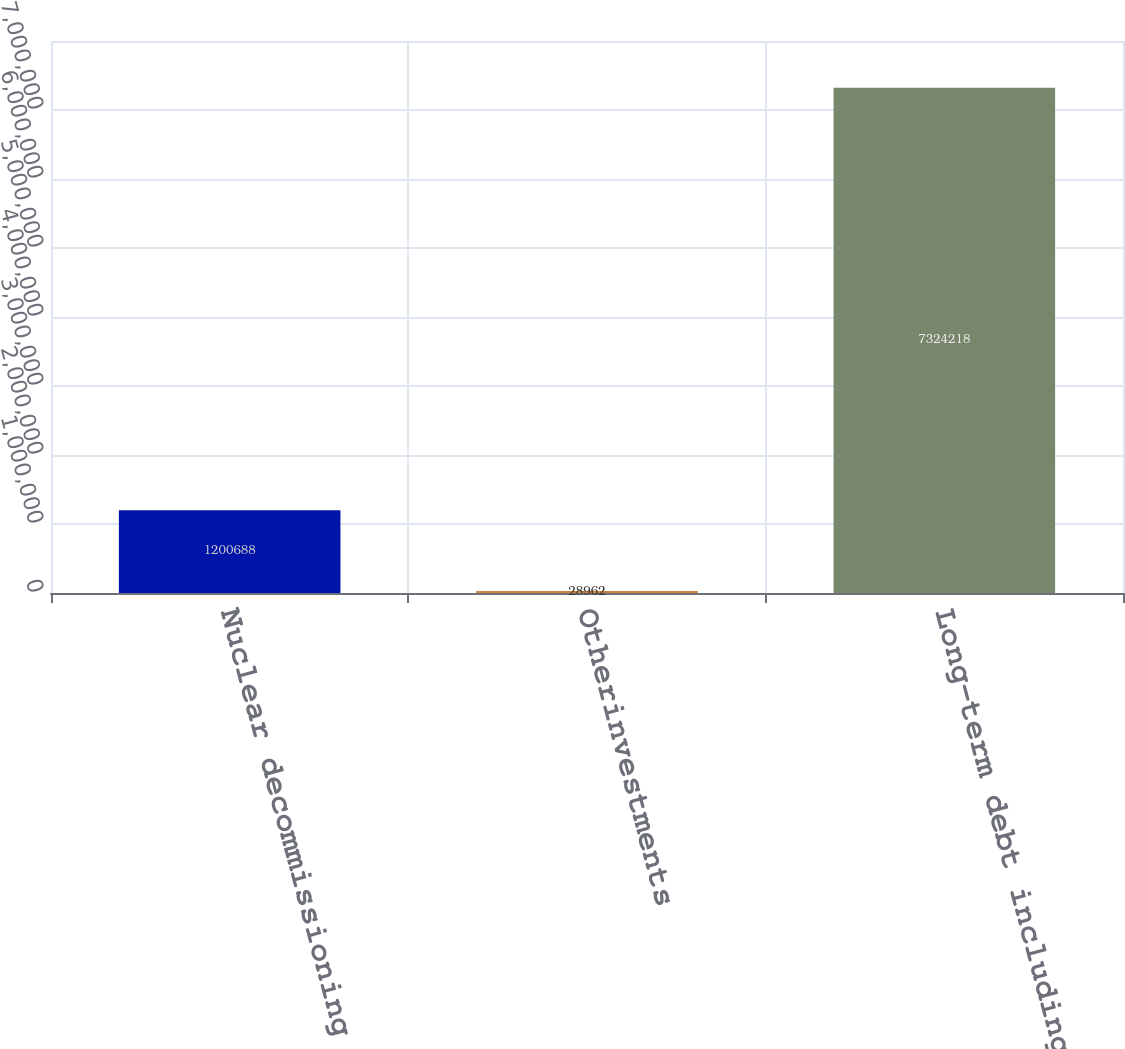<chart> <loc_0><loc_0><loc_500><loc_500><bar_chart><fcel>Nuclear decommissioning fund<fcel>Otherinvestments<fcel>Long-term debt including<nl><fcel>1.20069e+06<fcel>28962<fcel>7.32422e+06<nl></chart> 